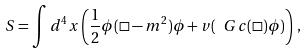Convert formula to latex. <formula><loc_0><loc_0><loc_500><loc_500>S = \int d ^ { 4 } x \left ( \frac { 1 } { 2 } \phi ( \Box - m ^ { 2 } ) \phi + v ( \ G c ( \Box ) \phi ) \right ) \, ,</formula> 